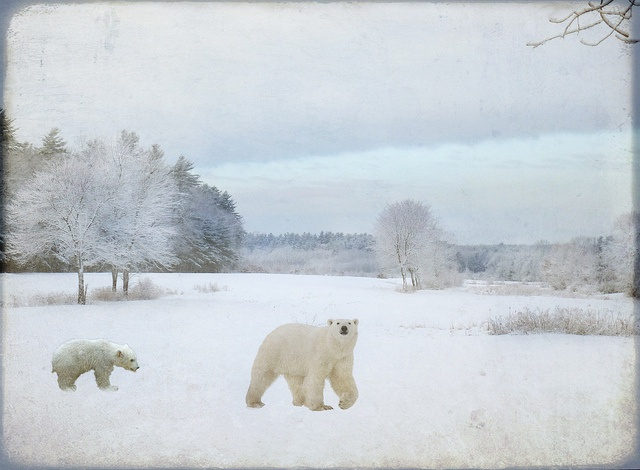Describe the objects in this image and their specific colors. I can see bear in gray, tan, darkgray, and lightgray tones and bear in gray, darkgray, and lightgray tones in this image. 